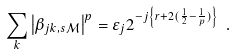<formula> <loc_0><loc_0><loc_500><loc_500>\sum _ { k } \left | \beta _ { j k , s \mathcal { M } } \right | ^ { p } = \varepsilon _ { j } 2 ^ { - j \left \{ r + 2 ( \frac { 1 } { 2 } - \frac { 1 } { p } ) \right \} } \text { } .</formula> 